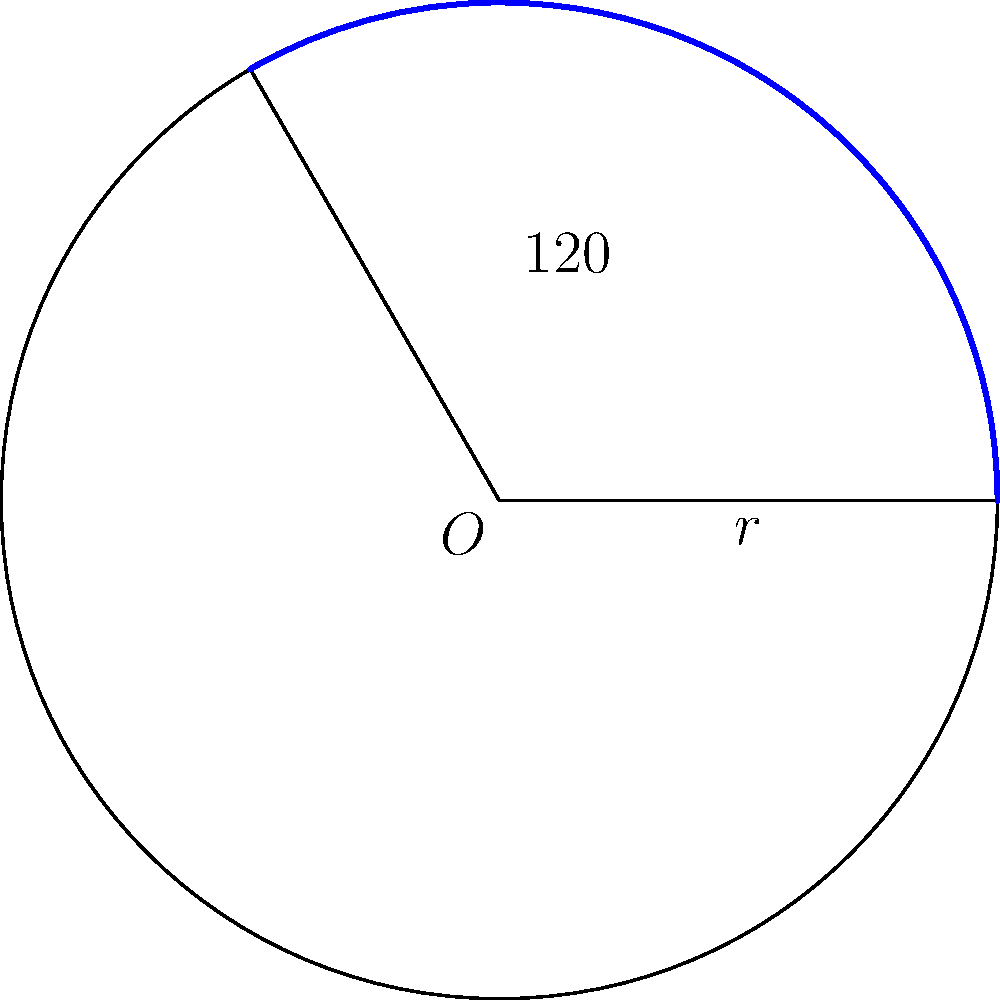In a circular sector with radius $r = 5$ cm and central angle $120°$, calculate the area of the sector. Round your answer to two decimal places. To calculate the area of a circular sector, we use the formula:

$$A = \frac{\theta}{360°} \pi r^2$$

Where:
$A$ is the area of the sector
$\theta$ is the central angle in degrees
$r$ is the radius

Let's substitute the given values:
$\theta = 120°$
$r = 5$ cm

Step 1: Plug the values into the formula
$$A = \frac{120°}{360°} \pi (5 \text{ cm})^2$$

Step 2: Simplify the fraction
$$A = \frac{1}{3} \pi (25 \text{ cm}^2)$$

Step 3: Calculate $\pi \times 25$
$$A = \frac{1}{3} \times 78.54 \text{ cm}^2$$

Step 4: Divide by 3
$$A = 26.18 \text{ cm}^2$$

Rounding to two decimal places, we get 26.18 cm².
Answer: 26.18 cm² 